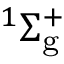Convert formula to latex. <formula><loc_0><loc_0><loc_500><loc_500>^ { 1 } \Sigma _ { g } ^ { + }</formula> 